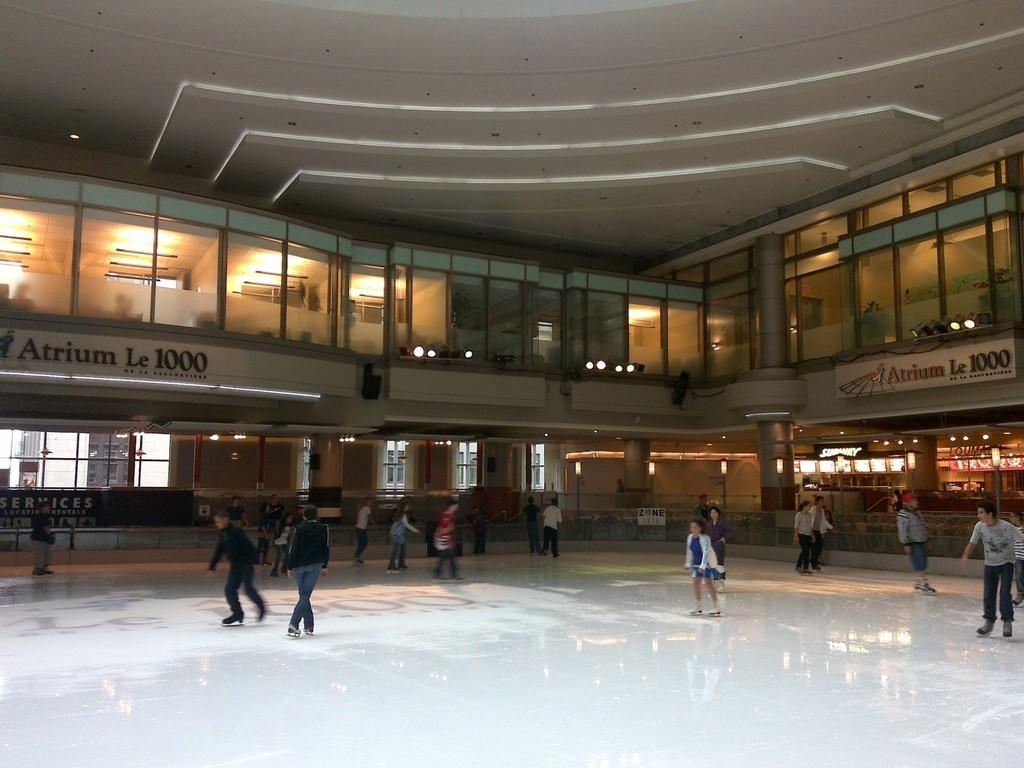Describe this image in one or two sentences. In this image we can see a building with windows, pillars, lights, name board and a roof. We can also see a group of people skating on the floor. 